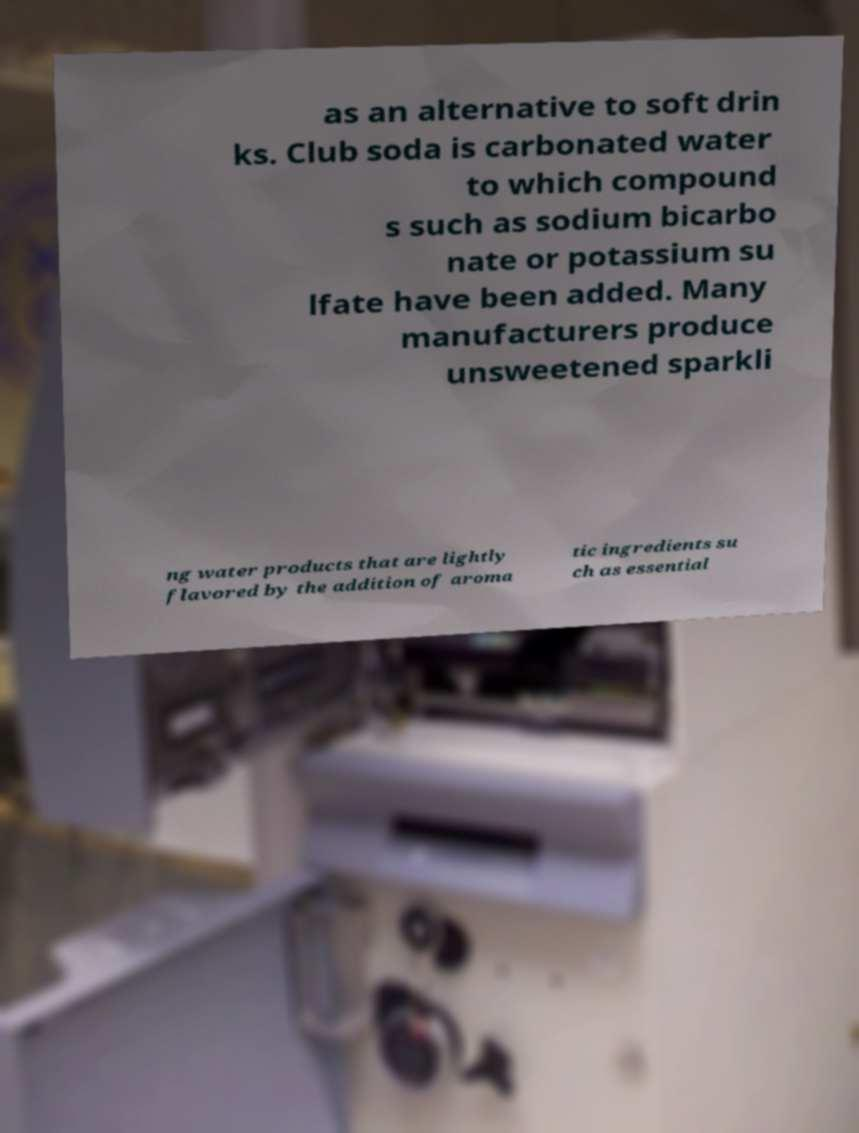What messages or text are displayed in this image? I need them in a readable, typed format. as an alternative to soft drin ks. Club soda is carbonated water to which compound s such as sodium bicarbo nate or potassium su lfate have been added. Many manufacturers produce unsweetened sparkli ng water products that are lightly flavored by the addition of aroma tic ingredients su ch as essential 